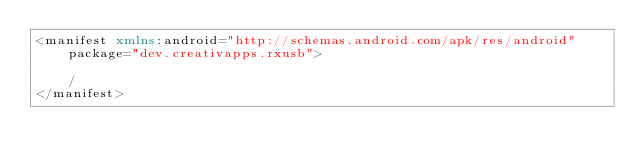<code> <loc_0><loc_0><loc_500><loc_500><_XML_><manifest xmlns:android="http://schemas.android.com/apk/res/android"
    package="dev.creativapps.rxusb">

    /
</manifest></code> 